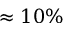Convert formula to latex. <formula><loc_0><loc_0><loc_500><loc_500>\approx 1 0 \%</formula> 